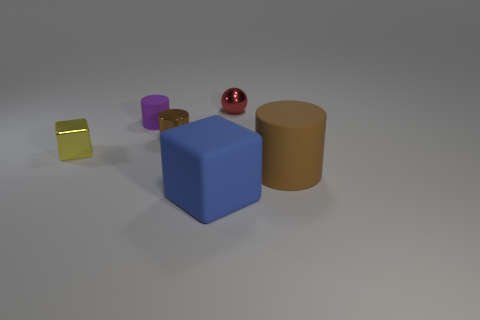Is there a tiny brown shiny thing that is behind the thing that is right of the tiny red object right of the blue matte block?
Make the answer very short. Yes. Is the number of small metallic spheres that are in front of the small brown shiny cylinder less than the number of green cylinders?
Your answer should be compact. No. How many other objects are the same shape as the tiny brown metal object?
Offer a very short reply. 2. What number of objects are either big things that are behind the blue matte block or matte things that are behind the tiny shiny block?
Offer a very short reply. 2. How big is the cylinder that is in front of the tiny purple cylinder and on the left side of the tiny red metal sphere?
Your answer should be compact. Small. There is a red object behind the yellow thing; does it have the same shape as the large blue matte thing?
Provide a short and direct response. No. How big is the rubber object that is in front of the matte cylinder that is to the right of the shiny ball right of the yellow thing?
Your answer should be very brief. Large. The other cylinder that is the same color as the tiny metallic cylinder is what size?
Keep it short and to the point. Large. How many objects are small red cubes or small metal balls?
Offer a terse response. 1. What shape is the object that is in front of the purple thing and left of the brown metal cylinder?
Ensure brevity in your answer.  Cube. 